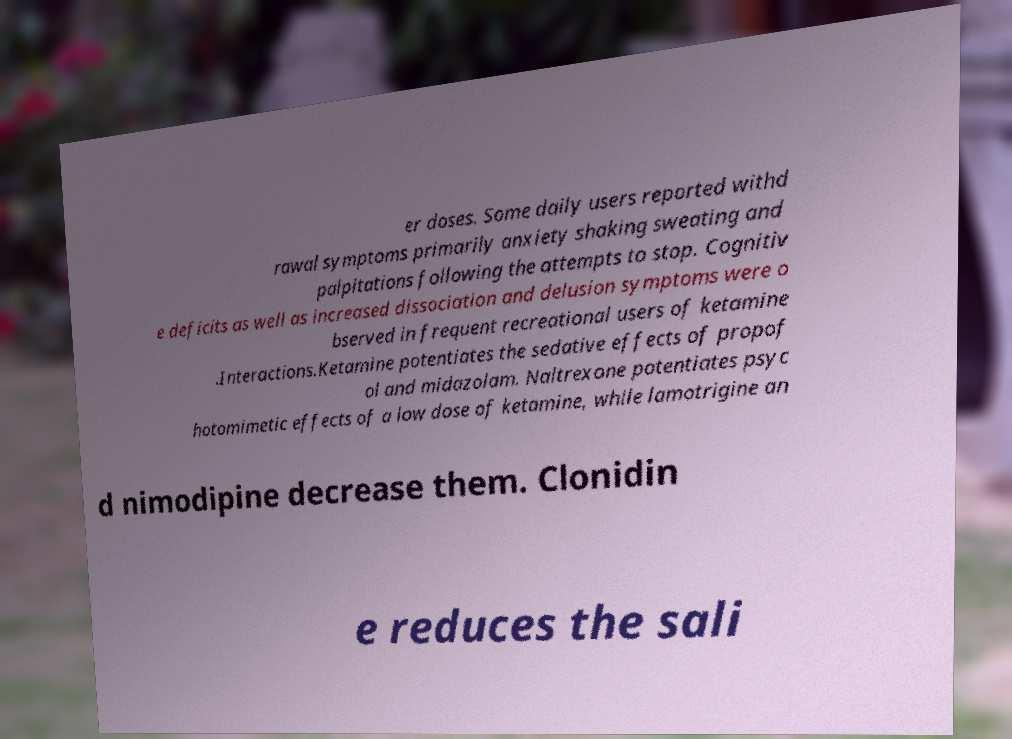Can you accurately transcribe the text from the provided image for me? er doses. Some daily users reported withd rawal symptoms primarily anxiety shaking sweating and palpitations following the attempts to stop. Cognitiv e deficits as well as increased dissociation and delusion symptoms were o bserved in frequent recreational users of ketamine .Interactions.Ketamine potentiates the sedative effects of propof ol and midazolam. Naltrexone potentiates psyc hotomimetic effects of a low dose of ketamine, while lamotrigine an d nimodipine decrease them. Clonidin e reduces the sali 